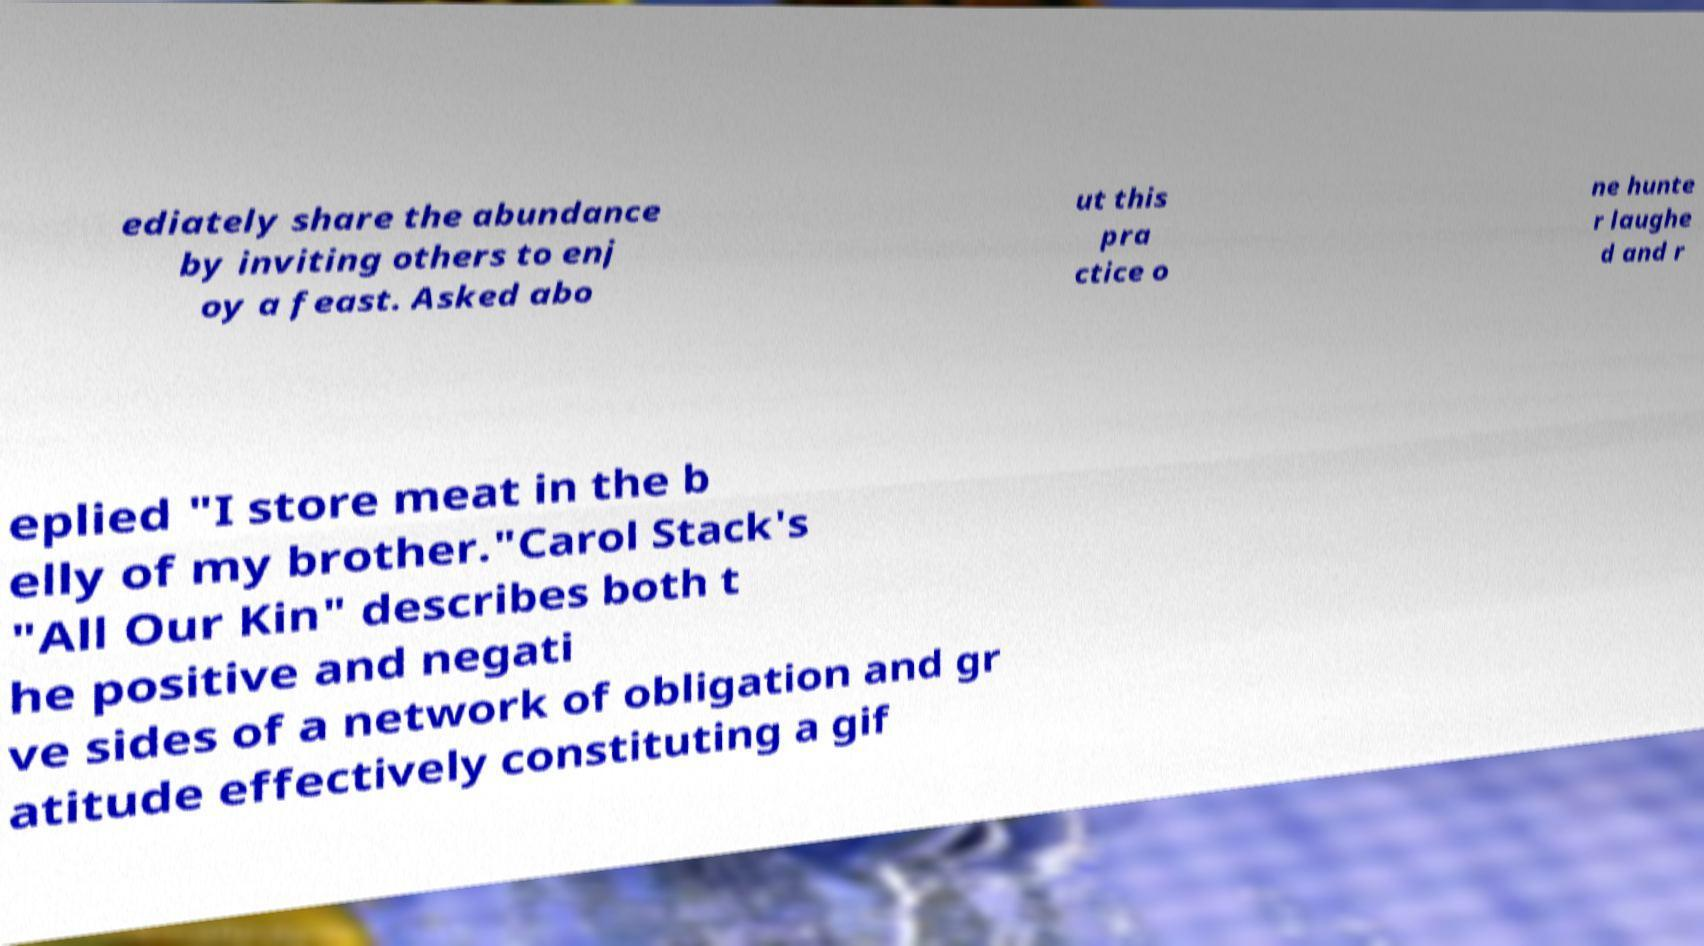Please read and relay the text visible in this image. What does it say? ediately share the abundance by inviting others to enj oy a feast. Asked abo ut this pra ctice o ne hunte r laughe d and r eplied "I store meat in the b elly of my brother."Carol Stack's "All Our Kin" describes both t he positive and negati ve sides of a network of obligation and gr atitude effectively constituting a gif 